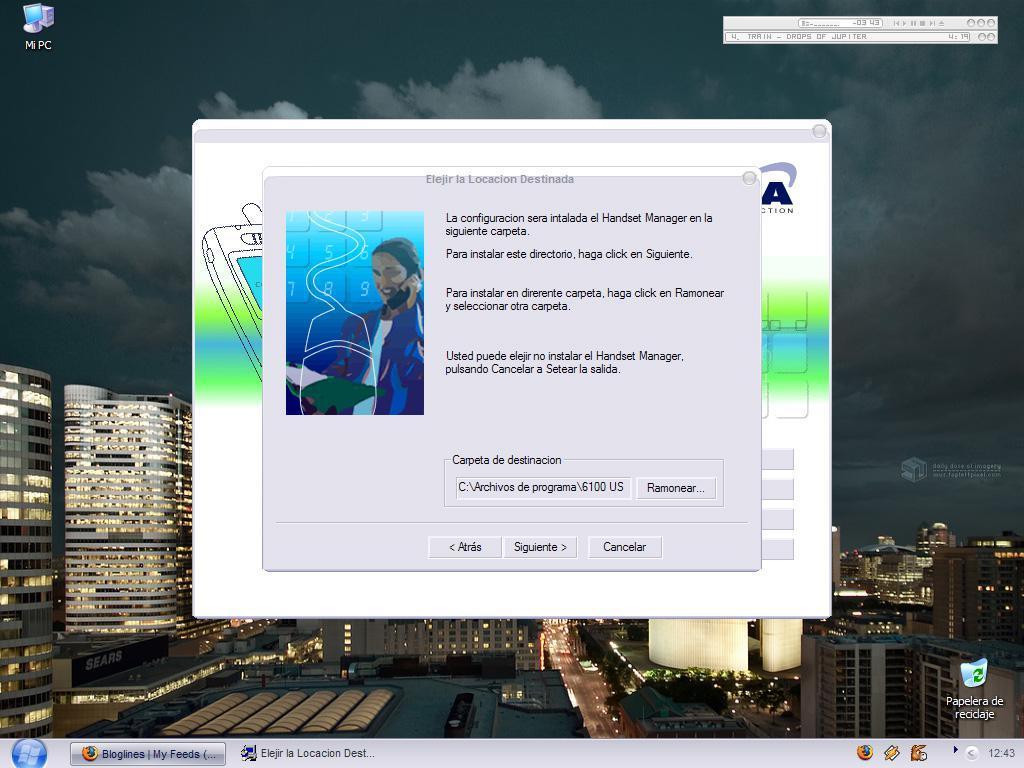Please provide a concise description of this image. In this image we can see the display screen of a desktop. 